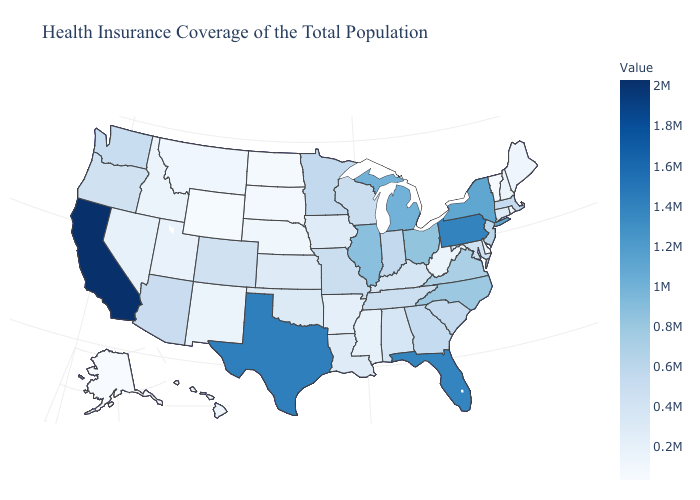Does California have the highest value in the USA?
Keep it brief. Yes. Does Indiana have the lowest value in the MidWest?
Give a very brief answer. No. 